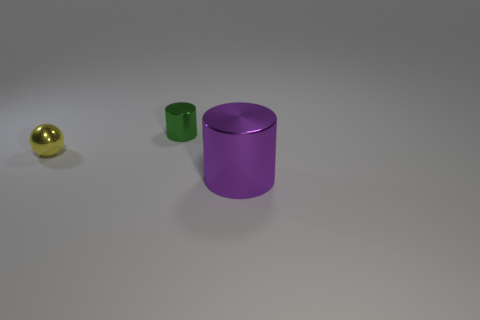Add 1 tiny yellow blocks. How many objects exist? 4 Subtract all purple cylinders. How many cylinders are left? 1 Subtract all red rubber blocks. Subtract all purple objects. How many objects are left? 2 Add 2 cylinders. How many cylinders are left? 4 Add 2 big red metallic cylinders. How many big red metallic cylinders exist? 2 Subtract 0 brown balls. How many objects are left? 3 Subtract all cylinders. How many objects are left? 1 Subtract 1 cylinders. How many cylinders are left? 1 Subtract all brown cylinders. Subtract all purple blocks. How many cylinders are left? 2 